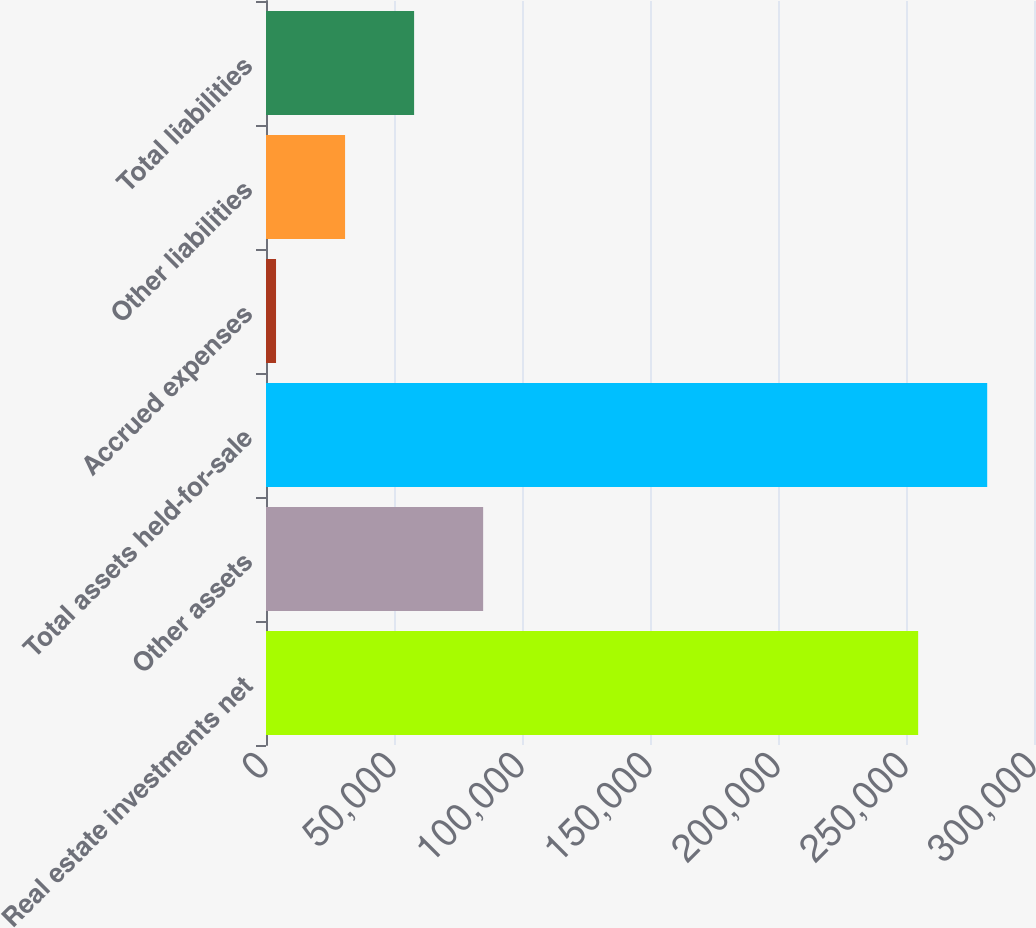<chart> <loc_0><loc_0><loc_500><loc_500><bar_chart><fcel>Real estate investments net<fcel>Other assets<fcel>Total assets held-for-sale<fcel>Accrued expenses<fcel>Other liabilities<fcel>Total liabilities<nl><fcel>254750<fcel>84820.6<fcel>281717<fcel>3919<fcel>30886.2<fcel>57853.4<nl></chart> 